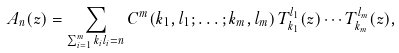<formula> <loc_0><loc_0><loc_500><loc_500>A _ { n } ( z ) = \sum _ { \sum _ { i = 1 } ^ { m } k _ { i } l _ { i } = n } C ^ { m } ( k _ { 1 } , l _ { 1 } ; \dots ; k _ { m } , l _ { m } ) \, T _ { k _ { 1 } } ^ { l _ { 1 } } ( z ) \cdots T _ { k _ { m } } ^ { l _ { m } } ( z ) ,</formula> 